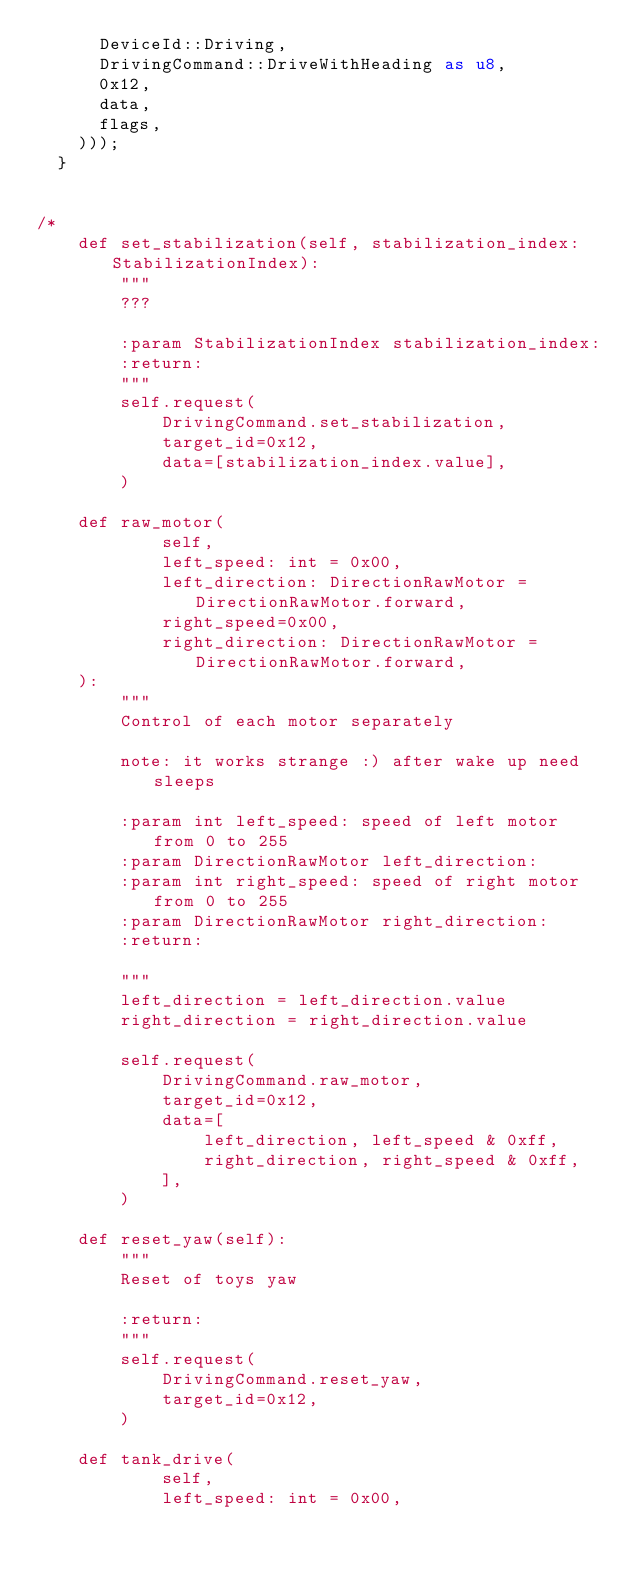Convert code to text. <code><loc_0><loc_0><loc_500><loc_500><_Rust_>      DeviceId::Driving,
      DrivingCommand::DriveWithHeading as u8,
      0x12,
      data,
      flags,
    )));
  }


/*
    def set_stabilization(self, stabilization_index: StabilizationIndex):
        """
        ???

        :param StabilizationIndex stabilization_index:
        :return:
        """
        self.request(
            DrivingCommand.set_stabilization,
            target_id=0x12,
            data=[stabilization_index.value],
        )

    def raw_motor(
            self,
            left_speed: int = 0x00,
            left_direction: DirectionRawMotor = DirectionRawMotor.forward,
            right_speed=0x00,
            right_direction: DirectionRawMotor = DirectionRawMotor.forward,
    ):
        """
        Control of each motor separately

        note: it works strange :) after wake up need sleeps

        :param int left_speed: speed of left motor from 0 to 255
        :param DirectionRawMotor left_direction:
        :param int right_speed: speed of right motor from 0 to 255
        :param DirectionRawMotor right_direction:
        :return:

        """
        left_direction = left_direction.value
        right_direction = right_direction.value

        self.request(
            DrivingCommand.raw_motor,
            target_id=0x12,
            data=[
                left_direction, left_speed & 0xff,
                right_direction, right_speed & 0xff,
            ],
        )

    def reset_yaw(self):
        """
        Reset of toys yaw

        :return:
        """
        self.request(
            DrivingCommand.reset_yaw,
            target_id=0x12,
        )

    def tank_drive(
            self,
            left_speed: int = 0x00,</code> 